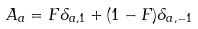<formula> <loc_0><loc_0><loc_500><loc_500>A _ { a } = F \delta _ { a , 1 } + ( 1 - F ) \delta _ { a , - 1 }</formula> 